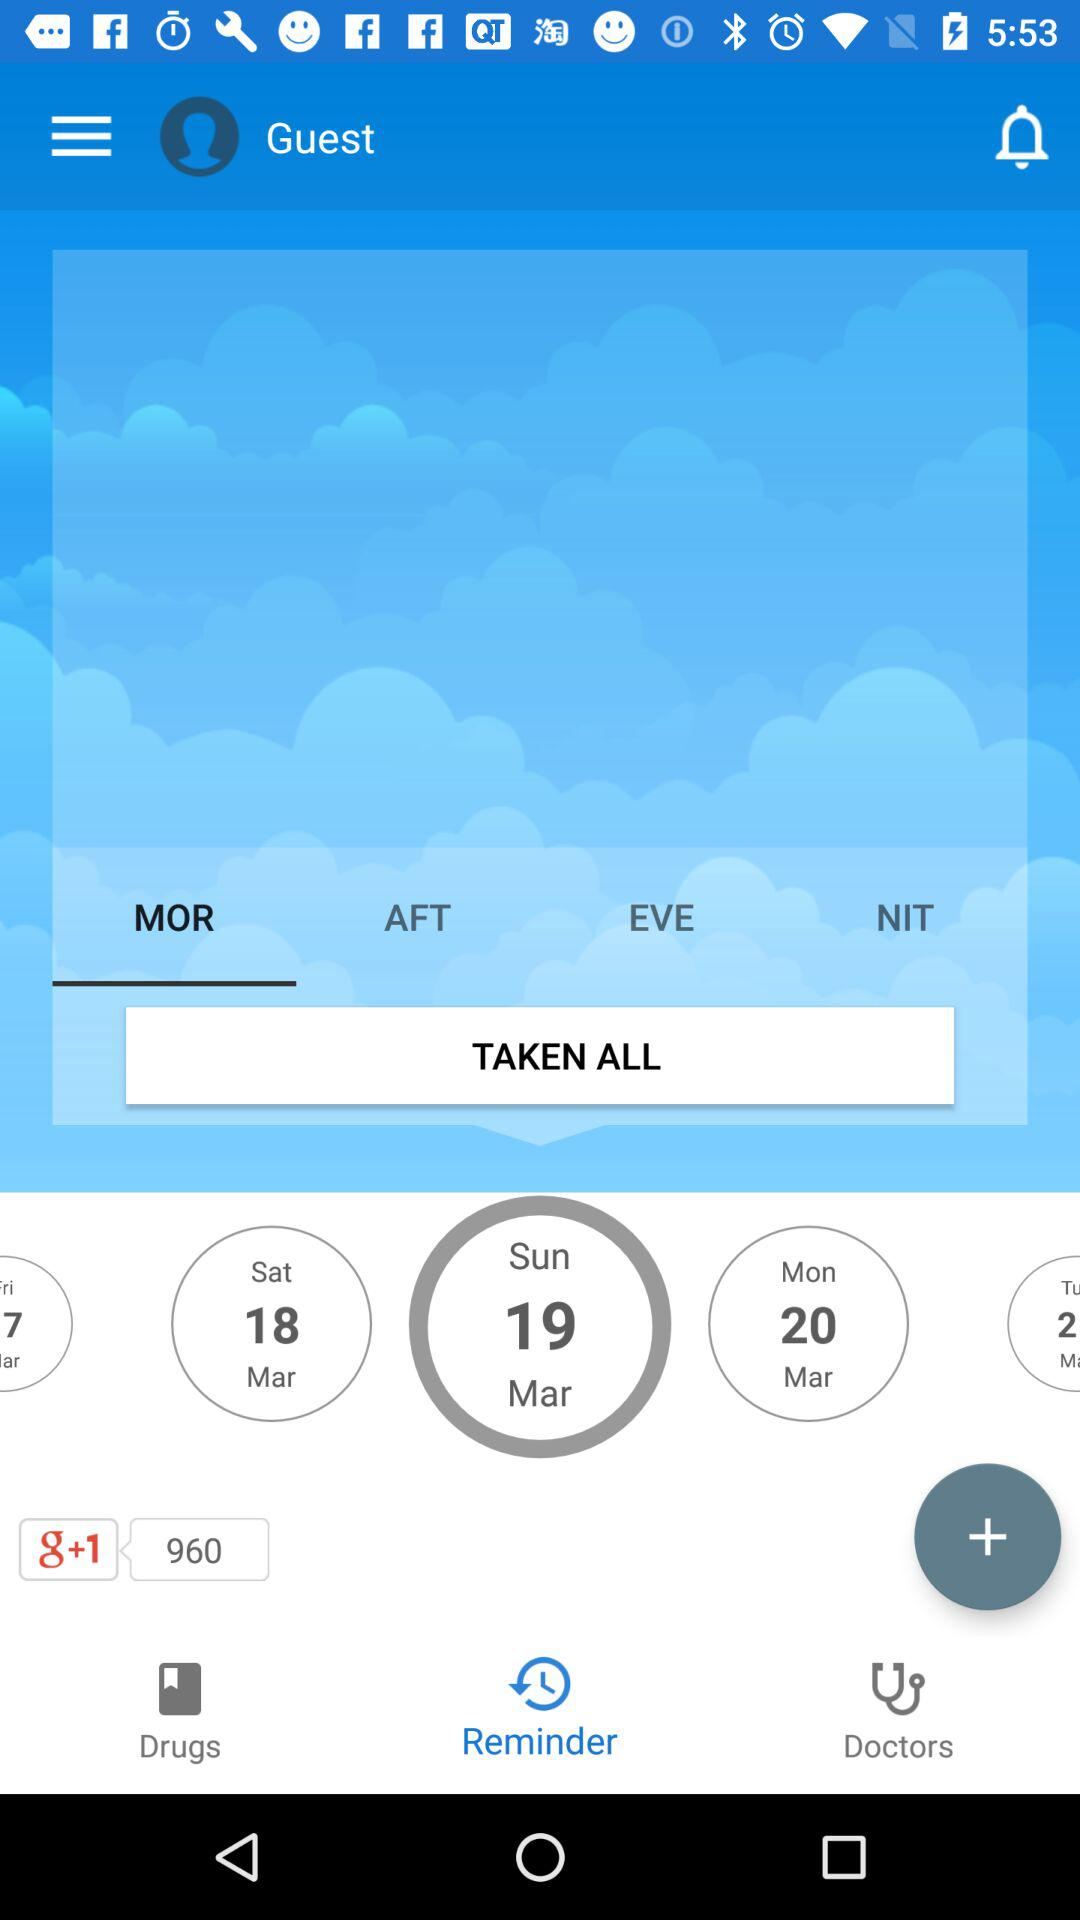How many days are in the week shown?
Answer the question using a single word or phrase. 5 